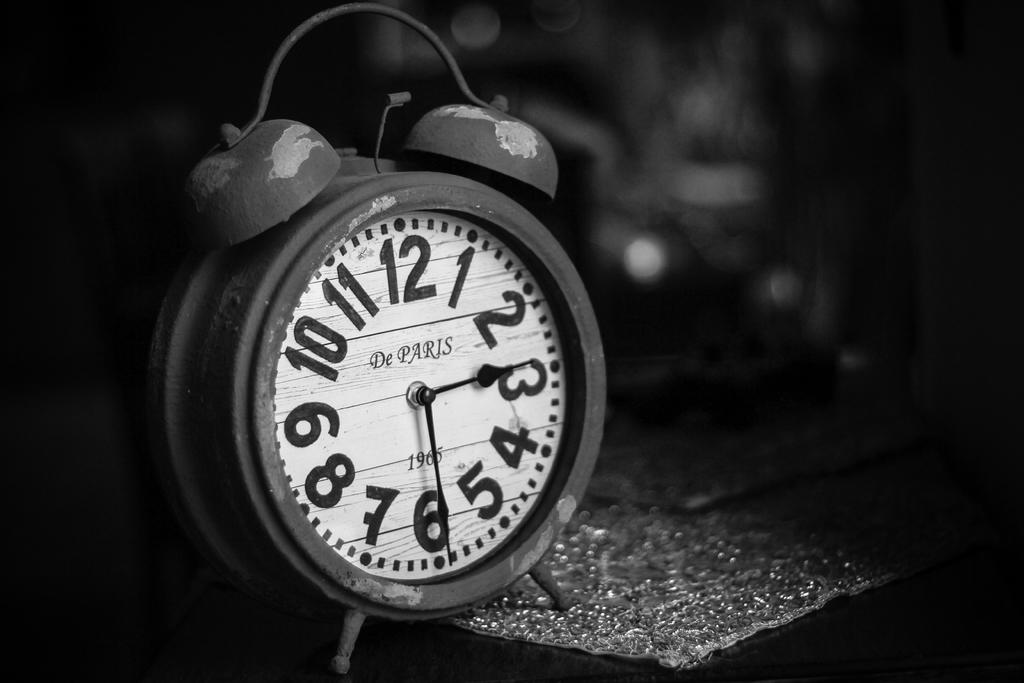<image>
Describe the image concisely. A 1965 alarm clock shows that it is 2:30. 